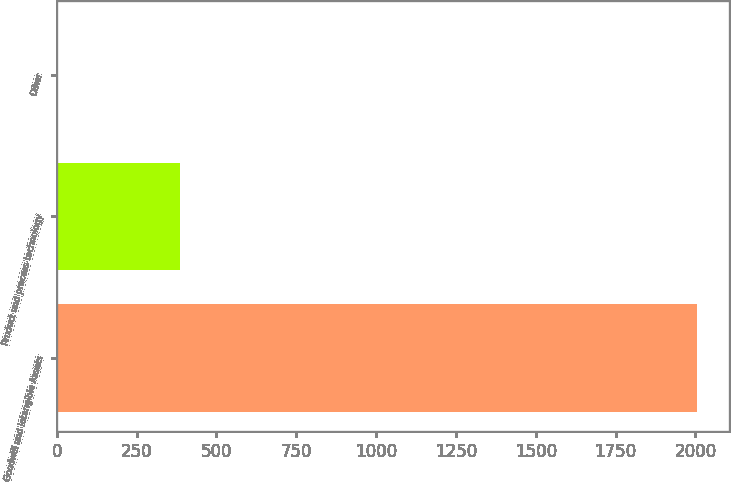Convert chart. <chart><loc_0><loc_0><loc_500><loc_500><bar_chart><fcel>Goodwill and Intangible Assets<fcel>Product and process technology<fcel>Other<nl><fcel>2005<fcel>385<fcel>5<nl></chart> 